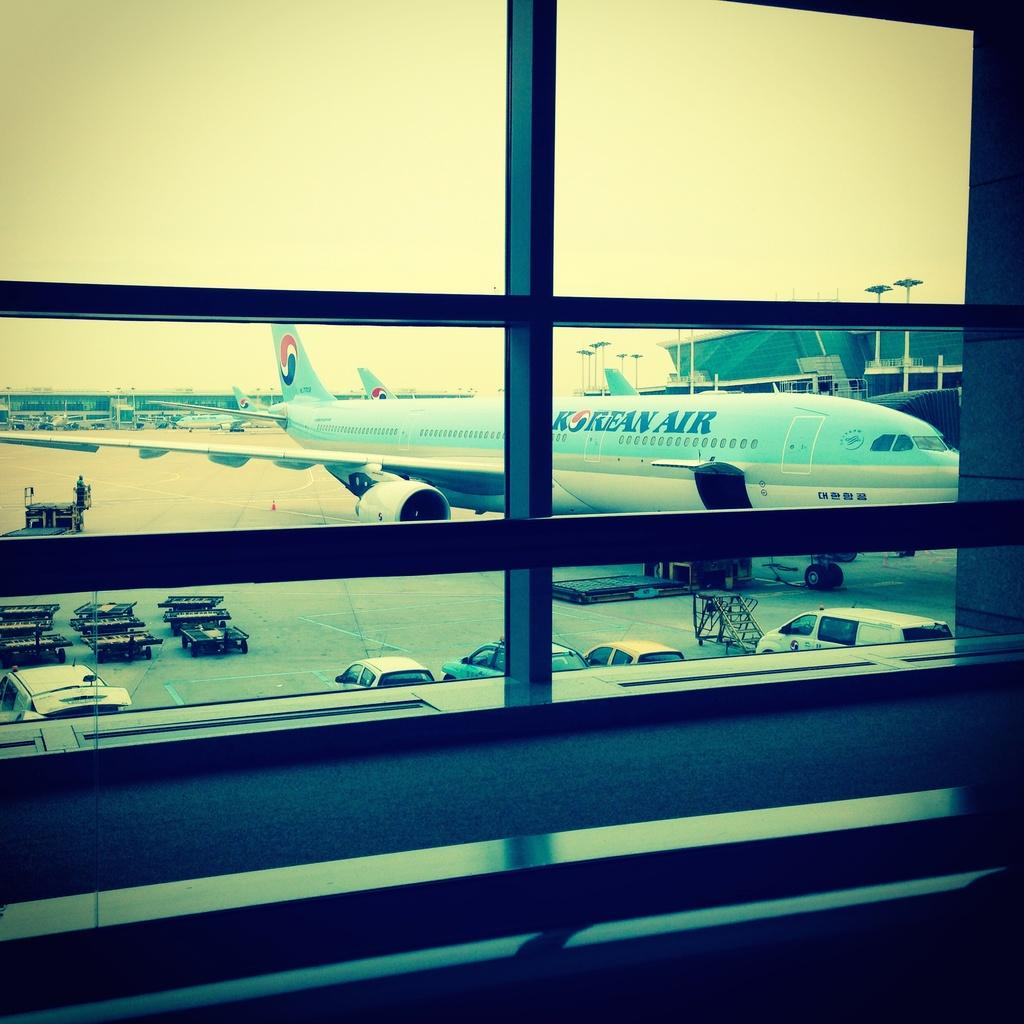<image>
Give a short and clear explanation of the subsequent image. A view from inside of a building of a Korean Air plane on a runway. 